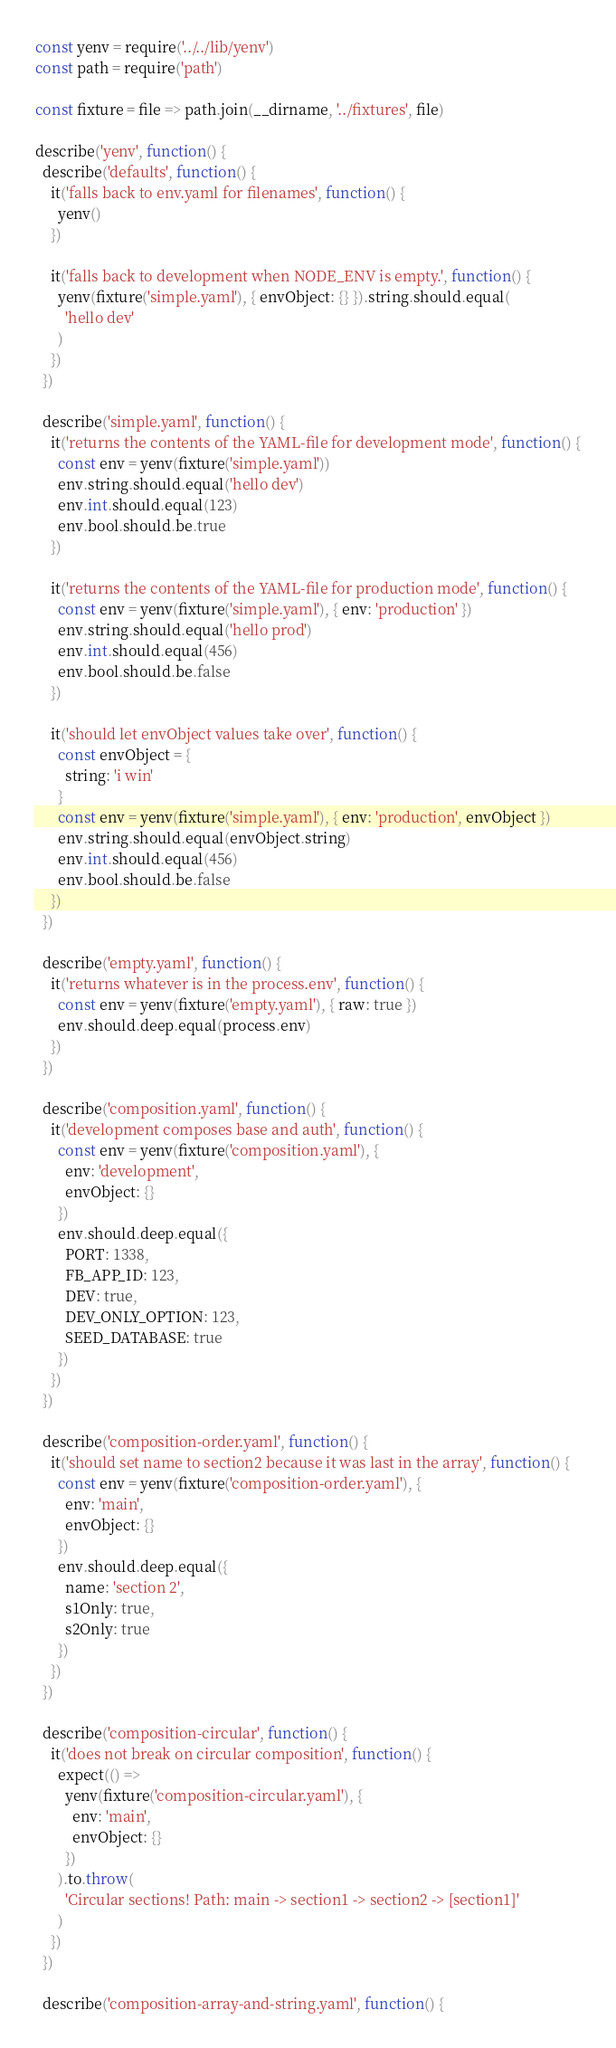<code> <loc_0><loc_0><loc_500><loc_500><_JavaScript_>const yenv = require('../../lib/yenv')
const path = require('path')

const fixture = file => path.join(__dirname, '../fixtures', file)

describe('yenv', function() {
  describe('defaults', function() {
    it('falls back to env.yaml for filenames', function() {
      yenv()
    })

    it('falls back to development when NODE_ENV is empty.', function() {
      yenv(fixture('simple.yaml'), { envObject: {} }).string.should.equal(
        'hello dev'
      )
    })
  })

  describe('simple.yaml', function() {
    it('returns the contents of the YAML-file for development mode', function() {
      const env = yenv(fixture('simple.yaml'))
      env.string.should.equal('hello dev')
      env.int.should.equal(123)
      env.bool.should.be.true
    })

    it('returns the contents of the YAML-file for production mode', function() {
      const env = yenv(fixture('simple.yaml'), { env: 'production' })
      env.string.should.equal('hello prod')
      env.int.should.equal(456)
      env.bool.should.be.false
    })

    it('should let envObject values take over', function() {
      const envObject = {
        string: 'i win'
      }
      const env = yenv(fixture('simple.yaml'), { env: 'production', envObject })
      env.string.should.equal(envObject.string)
      env.int.should.equal(456)
      env.bool.should.be.false
    })
  })

  describe('empty.yaml', function() {
    it('returns whatever is in the process.env', function() {
      const env = yenv(fixture('empty.yaml'), { raw: true })
      env.should.deep.equal(process.env)
    })
  })

  describe('composition.yaml', function() {
    it('development composes base and auth', function() {
      const env = yenv(fixture('composition.yaml'), {
        env: 'development',
        envObject: {}
      })
      env.should.deep.equal({
        PORT: 1338,
        FB_APP_ID: 123,
        DEV: true,
        DEV_ONLY_OPTION: 123,
        SEED_DATABASE: true
      })
    })
  })

  describe('composition-order.yaml', function() {
    it('should set name to section2 because it was last in the array', function() {
      const env = yenv(fixture('composition-order.yaml'), {
        env: 'main',
        envObject: {}
      })
      env.should.deep.equal({
        name: 'section 2',
        s1Only: true,
        s2Only: true
      })
    })
  })

  describe('composition-circular', function() {
    it('does not break on circular composition', function() {
      expect(() =>
        yenv(fixture('composition-circular.yaml'), {
          env: 'main',
          envObject: {}
        })
      ).to.throw(
        'Circular sections! Path: main -> section1 -> section2 -> [section1]'
      )
    })
  })

  describe('composition-array-and-string.yaml', function() {</code> 